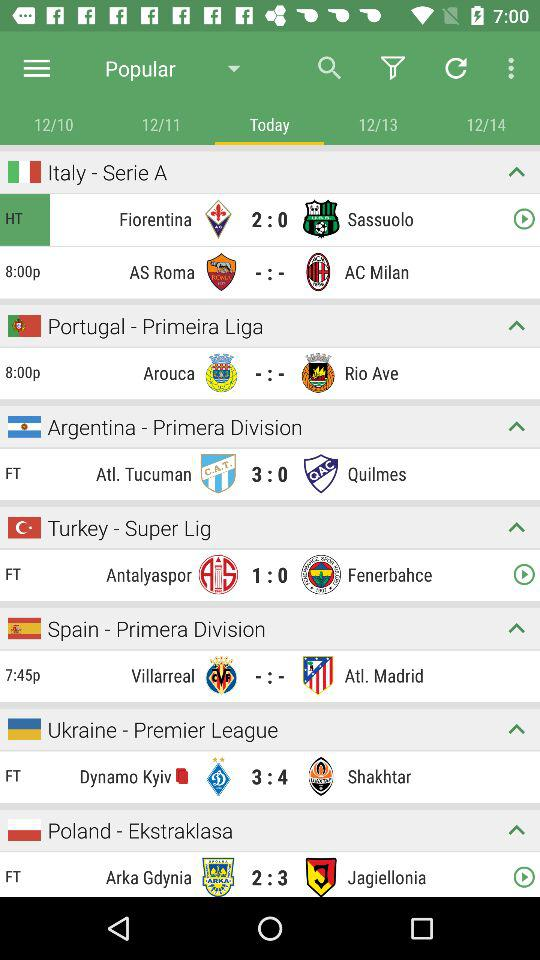Which two teams are played in "Turkey - Super Lig"? The teams are "Antalyaspor" and "Fenerbahce". 